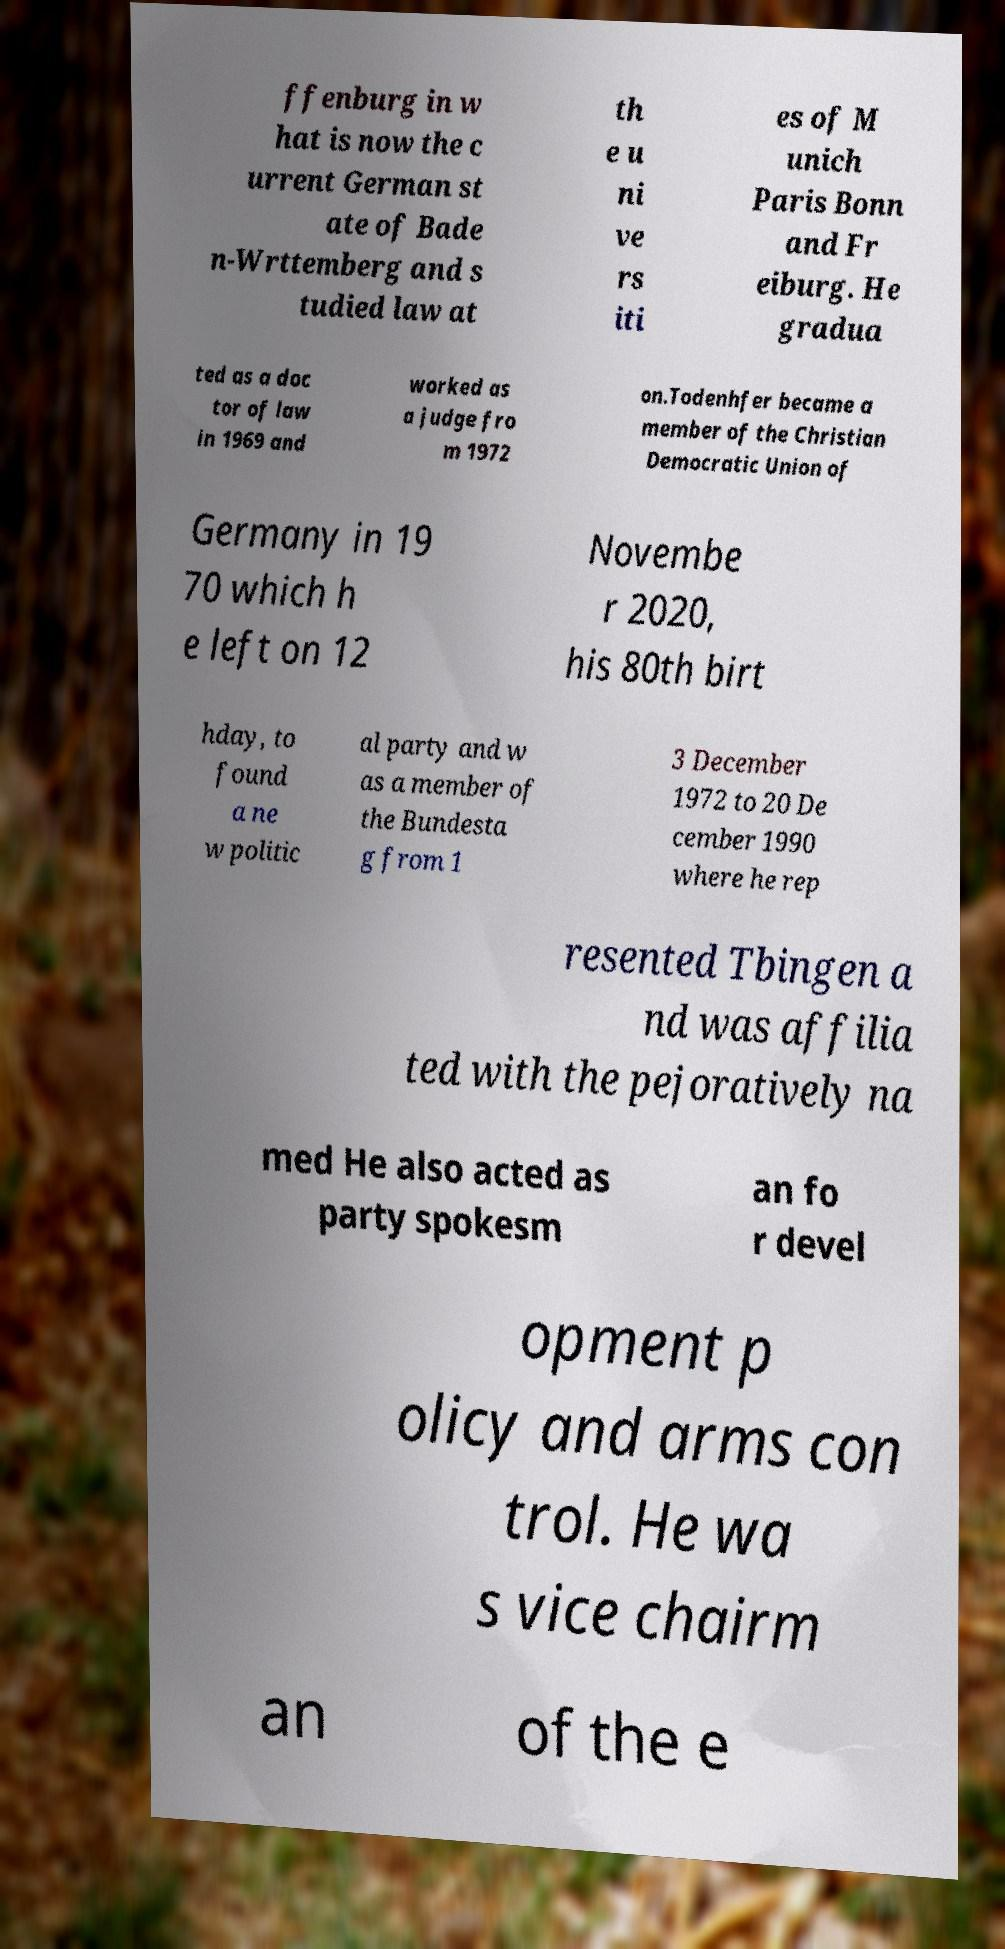For documentation purposes, I need the text within this image transcribed. Could you provide that? ffenburg in w hat is now the c urrent German st ate of Bade n-Wrttemberg and s tudied law at th e u ni ve rs iti es of M unich Paris Bonn and Fr eiburg. He gradua ted as a doc tor of law in 1969 and worked as a judge fro m 1972 on.Todenhfer became a member of the Christian Democratic Union of Germany in 19 70 which h e left on 12 Novembe r 2020, his 80th birt hday, to found a ne w politic al party and w as a member of the Bundesta g from 1 3 December 1972 to 20 De cember 1990 where he rep resented Tbingen a nd was affilia ted with the pejoratively na med He also acted as party spokesm an fo r devel opment p olicy and arms con trol. He wa s vice chairm an of the e 